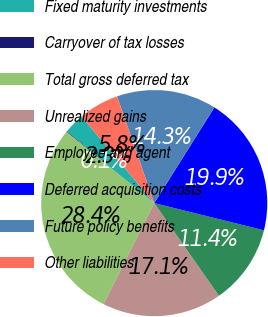Convert chart to OTSL. <chart><loc_0><loc_0><loc_500><loc_500><pie_chart><fcel>Fixed maturity investments<fcel>Carryover of tax losses<fcel>Total gross deferred tax<fcel>Unrealized gains<fcel>Employee and agent<fcel>Deferred acquisition costs<fcel>Future policy benefits<fcel>Other liabilities<nl><fcel>2.94%<fcel>0.1%<fcel>28.44%<fcel>17.1%<fcel>11.44%<fcel>19.94%<fcel>14.27%<fcel>5.77%<nl></chart> 